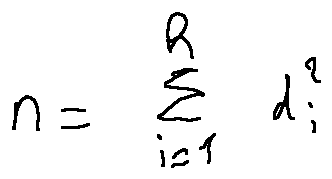<formula> <loc_0><loc_0><loc_500><loc_500>n = \sum \lim i t s _ { i = 1 } ^ { h } d _ { i } ^ { 2 }</formula> 